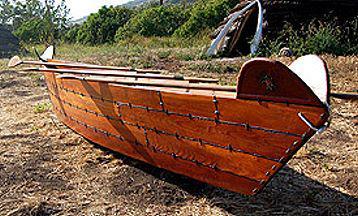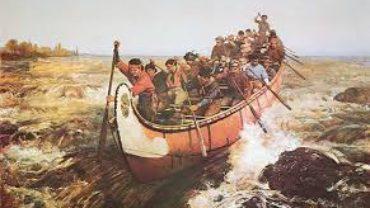The first image is the image on the left, the second image is the image on the right. Evaluate the accuracy of this statement regarding the images: "In one image there are six or more men in a boat being paddled through water.". Is it true? Answer yes or no. Yes. 